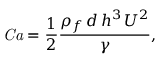Convert formula to latex. <formula><loc_0><loc_0><loc_500><loc_500>C a = \frac { 1 } { 2 } \frac { \rho _ { f } \, d \, h ^ { 3 } \, U ^ { 2 } } { \gamma } ,</formula> 